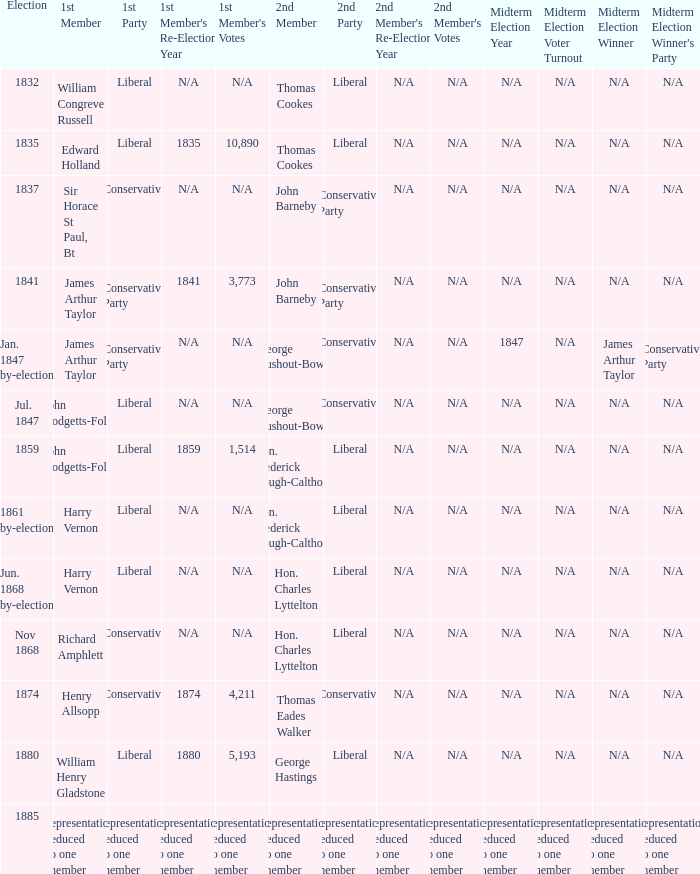What was the 1st Member when the 1st Party had its representation reduced to one member? Representation reduced to one member. 